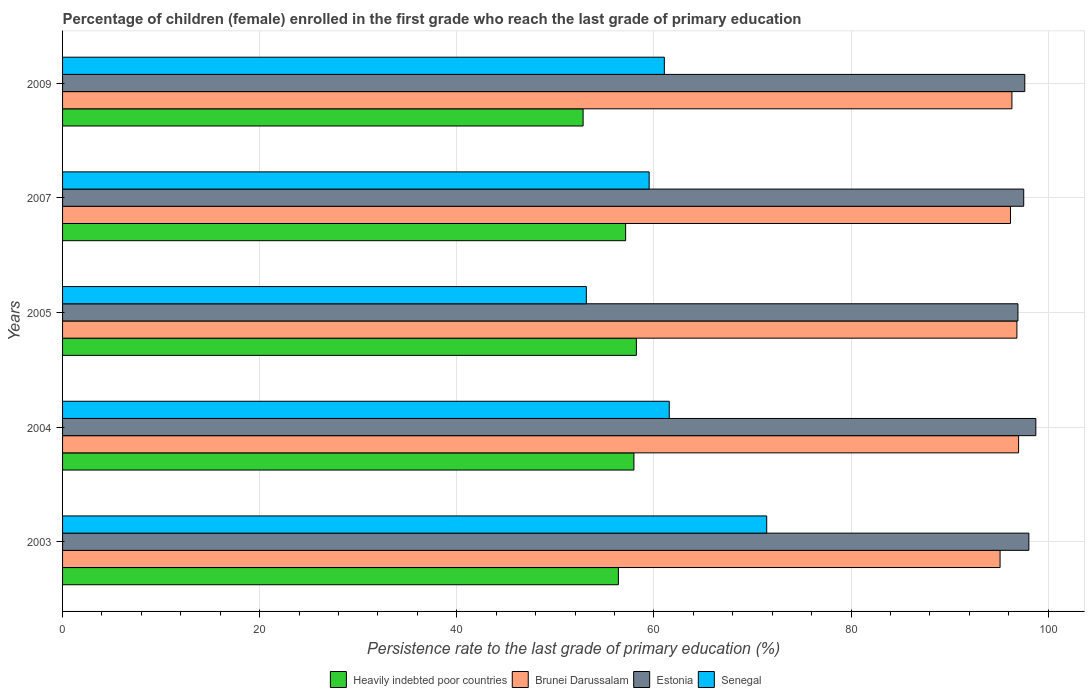Are the number of bars on each tick of the Y-axis equal?
Your response must be concise. Yes. How many bars are there on the 4th tick from the top?
Provide a short and direct response. 4. What is the label of the 3rd group of bars from the top?
Your answer should be compact. 2005. What is the persistence rate of children in Brunei Darussalam in 2003?
Offer a terse response. 95.13. Across all years, what is the maximum persistence rate of children in Estonia?
Give a very brief answer. 98.75. Across all years, what is the minimum persistence rate of children in Estonia?
Make the answer very short. 96.94. In which year was the persistence rate of children in Estonia maximum?
Your answer should be compact. 2004. In which year was the persistence rate of children in Brunei Darussalam minimum?
Give a very brief answer. 2003. What is the total persistence rate of children in Estonia in the graph?
Keep it short and to the point. 488.9. What is the difference between the persistence rate of children in Heavily indebted poor countries in 2003 and that in 2005?
Make the answer very short. -1.83. What is the difference between the persistence rate of children in Brunei Darussalam in 2005 and the persistence rate of children in Heavily indebted poor countries in 2003?
Make the answer very short. 40.44. What is the average persistence rate of children in Senegal per year?
Your answer should be compact. 61.35. In the year 2009, what is the difference between the persistence rate of children in Brunei Darussalam and persistence rate of children in Heavily indebted poor countries?
Keep it short and to the point. 43.51. What is the ratio of the persistence rate of children in Heavily indebted poor countries in 2003 to that in 2004?
Ensure brevity in your answer.  0.97. Is the persistence rate of children in Brunei Darussalam in 2005 less than that in 2009?
Give a very brief answer. No. Is the difference between the persistence rate of children in Brunei Darussalam in 2004 and 2009 greater than the difference between the persistence rate of children in Heavily indebted poor countries in 2004 and 2009?
Your response must be concise. No. What is the difference between the highest and the second highest persistence rate of children in Senegal?
Make the answer very short. 9.89. What is the difference between the highest and the lowest persistence rate of children in Heavily indebted poor countries?
Ensure brevity in your answer.  5.4. Is the sum of the persistence rate of children in Heavily indebted poor countries in 2003 and 2004 greater than the maximum persistence rate of children in Brunei Darussalam across all years?
Offer a very short reply. Yes. What does the 1st bar from the top in 2003 represents?
Your response must be concise. Senegal. What does the 2nd bar from the bottom in 2005 represents?
Make the answer very short. Brunei Darussalam. Are all the bars in the graph horizontal?
Your answer should be compact. Yes. What is the difference between two consecutive major ticks on the X-axis?
Your response must be concise. 20. Does the graph contain any zero values?
Your answer should be compact. No. Does the graph contain grids?
Provide a short and direct response. Yes. How many legend labels are there?
Make the answer very short. 4. How are the legend labels stacked?
Make the answer very short. Horizontal. What is the title of the graph?
Ensure brevity in your answer.  Percentage of children (female) enrolled in the first grade who reach the last grade of primary education. Does "Turks and Caicos Islands" appear as one of the legend labels in the graph?
Your answer should be very brief. No. What is the label or title of the X-axis?
Keep it short and to the point. Persistence rate to the last grade of primary education (%). What is the Persistence rate to the last grade of primary education (%) of Heavily indebted poor countries in 2003?
Provide a short and direct response. 56.4. What is the Persistence rate to the last grade of primary education (%) in Brunei Darussalam in 2003?
Offer a terse response. 95.13. What is the Persistence rate to the last grade of primary education (%) in Estonia in 2003?
Keep it short and to the point. 98.05. What is the Persistence rate to the last grade of primary education (%) in Senegal in 2003?
Ensure brevity in your answer.  71.45. What is the Persistence rate to the last grade of primary education (%) of Heavily indebted poor countries in 2004?
Offer a terse response. 57.97. What is the Persistence rate to the last grade of primary education (%) in Brunei Darussalam in 2004?
Offer a terse response. 97.01. What is the Persistence rate to the last grade of primary education (%) in Estonia in 2004?
Your response must be concise. 98.75. What is the Persistence rate to the last grade of primary education (%) of Senegal in 2004?
Your answer should be very brief. 61.56. What is the Persistence rate to the last grade of primary education (%) in Heavily indebted poor countries in 2005?
Keep it short and to the point. 58.22. What is the Persistence rate to the last grade of primary education (%) of Brunei Darussalam in 2005?
Ensure brevity in your answer.  96.83. What is the Persistence rate to the last grade of primary education (%) of Estonia in 2005?
Your answer should be compact. 96.94. What is the Persistence rate to the last grade of primary education (%) in Senegal in 2005?
Keep it short and to the point. 53.14. What is the Persistence rate to the last grade of primary education (%) of Heavily indebted poor countries in 2007?
Make the answer very short. 57.13. What is the Persistence rate to the last grade of primary education (%) in Brunei Darussalam in 2007?
Provide a succinct answer. 96.18. What is the Persistence rate to the last grade of primary education (%) of Estonia in 2007?
Give a very brief answer. 97.52. What is the Persistence rate to the last grade of primary education (%) of Senegal in 2007?
Your answer should be very brief. 59.52. What is the Persistence rate to the last grade of primary education (%) in Heavily indebted poor countries in 2009?
Provide a short and direct response. 52.82. What is the Persistence rate to the last grade of primary education (%) of Brunei Darussalam in 2009?
Offer a very short reply. 96.33. What is the Persistence rate to the last grade of primary education (%) of Estonia in 2009?
Your response must be concise. 97.63. What is the Persistence rate to the last grade of primary education (%) in Senegal in 2009?
Offer a very short reply. 61.06. Across all years, what is the maximum Persistence rate to the last grade of primary education (%) of Heavily indebted poor countries?
Offer a very short reply. 58.22. Across all years, what is the maximum Persistence rate to the last grade of primary education (%) of Brunei Darussalam?
Your answer should be compact. 97.01. Across all years, what is the maximum Persistence rate to the last grade of primary education (%) of Estonia?
Give a very brief answer. 98.75. Across all years, what is the maximum Persistence rate to the last grade of primary education (%) in Senegal?
Your answer should be compact. 71.45. Across all years, what is the minimum Persistence rate to the last grade of primary education (%) of Heavily indebted poor countries?
Make the answer very short. 52.82. Across all years, what is the minimum Persistence rate to the last grade of primary education (%) in Brunei Darussalam?
Ensure brevity in your answer.  95.13. Across all years, what is the minimum Persistence rate to the last grade of primary education (%) of Estonia?
Your response must be concise. 96.94. Across all years, what is the minimum Persistence rate to the last grade of primary education (%) in Senegal?
Give a very brief answer. 53.14. What is the total Persistence rate to the last grade of primary education (%) of Heavily indebted poor countries in the graph?
Keep it short and to the point. 282.54. What is the total Persistence rate to the last grade of primary education (%) in Brunei Darussalam in the graph?
Your answer should be very brief. 481.47. What is the total Persistence rate to the last grade of primary education (%) of Estonia in the graph?
Give a very brief answer. 488.9. What is the total Persistence rate to the last grade of primary education (%) of Senegal in the graph?
Give a very brief answer. 306.73. What is the difference between the Persistence rate to the last grade of primary education (%) in Heavily indebted poor countries in 2003 and that in 2004?
Provide a succinct answer. -1.58. What is the difference between the Persistence rate to the last grade of primary education (%) in Brunei Darussalam in 2003 and that in 2004?
Offer a very short reply. -1.88. What is the difference between the Persistence rate to the last grade of primary education (%) in Estonia in 2003 and that in 2004?
Ensure brevity in your answer.  -0.71. What is the difference between the Persistence rate to the last grade of primary education (%) in Senegal in 2003 and that in 2004?
Keep it short and to the point. 9.89. What is the difference between the Persistence rate to the last grade of primary education (%) of Heavily indebted poor countries in 2003 and that in 2005?
Offer a very short reply. -1.83. What is the difference between the Persistence rate to the last grade of primary education (%) of Brunei Darussalam in 2003 and that in 2005?
Your answer should be compact. -1.71. What is the difference between the Persistence rate to the last grade of primary education (%) in Estonia in 2003 and that in 2005?
Your response must be concise. 1.11. What is the difference between the Persistence rate to the last grade of primary education (%) of Senegal in 2003 and that in 2005?
Your answer should be compact. 18.3. What is the difference between the Persistence rate to the last grade of primary education (%) in Heavily indebted poor countries in 2003 and that in 2007?
Keep it short and to the point. -0.73. What is the difference between the Persistence rate to the last grade of primary education (%) in Brunei Darussalam in 2003 and that in 2007?
Your answer should be very brief. -1.06. What is the difference between the Persistence rate to the last grade of primary education (%) of Estonia in 2003 and that in 2007?
Give a very brief answer. 0.52. What is the difference between the Persistence rate to the last grade of primary education (%) in Senegal in 2003 and that in 2007?
Your answer should be compact. 11.93. What is the difference between the Persistence rate to the last grade of primary education (%) of Heavily indebted poor countries in 2003 and that in 2009?
Make the answer very short. 3.58. What is the difference between the Persistence rate to the last grade of primary education (%) of Brunei Darussalam in 2003 and that in 2009?
Your answer should be compact. -1.2. What is the difference between the Persistence rate to the last grade of primary education (%) in Estonia in 2003 and that in 2009?
Provide a short and direct response. 0.41. What is the difference between the Persistence rate to the last grade of primary education (%) in Senegal in 2003 and that in 2009?
Your answer should be compact. 10.39. What is the difference between the Persistence rate to the last grade of primary education (%) of Heavily indebted poor countries in 2004 and that in 2005?
Provide a short and direct response. -0.25. What is the difference between the Persistence rate to the last grade of primary education (%) in Brunei Darussalam in 2004 and that in 2005?
Your answer should be compact. 0.17. What is the difference between the Persistence rate to the last grade of primary education (%) in Estonia in 2004 and that in 2005?
Your answer should be compact. 1.81. What is the difference between the Persistence rate to the last grade of primary education (%) of Senegal in 2004 and that in 2005?
Provide a short and direct response. 8.41. What is the difference between the Persistence rate to the last grade of primary education (%) of Heavily indebted poor countries in 2004 and that in 2007?
Keep it short and to the point. 0.84. What is the difference between the Persistence rate to the last grade of primary education (%) of Brunei Darussalam in 2004 and that in 2007?
Offer a terse response. 0.82. What is the difference between the Persistence rate to the last grade of primary education (%) in Estonia in 2004 and that in 2007?
Your answer should be compact. 1.23. What is the difference between the Persistence rate to the last grade of primary education (%) of Senegal in 2004 and that in 2007?
Your answer should be very brief. 2.04. What is the difference between the Persistence rate to the last grade of primary education (%) in Heavily indebted poor countries in 2004 and that in 2009?
Provide a succinct answer. 5.16. What is the difference between the Persistence rate to the last grade of primary education (%) of Brunei Darussalam in 2004 and that in 2009?
Offer a terse response. 0.68. What is the difference between the Persistence rate to the last grade of primary education (%) in Estonia in 2004 and that in 2009?
Your response must be concise. 1.12. What is the difference between the Persistence rate to the last grade of primary education (%) of Senegal in 2004 and that in 2009?
Provide a short and direct response. 0.5. What is the difference between the Persistence rate to the last grade of primary education (%) in Heavily indebted poor countries in 2005 and that in 2007?
Provide a short and direct response. 1.09. What is the difference between the Persistence rate to the last grade of primary education (%) in Brunei Darussalam in 2005 and that in 2007?
Make the answer very short. 0.65. What is the difference between the Persistence rate to the last grade of primary education (%) in Estonia in 2005 and that in 2007?
Offer a very short reply. -0.59. What is the difference between the Persistence rate to the last grade of primary education (%) in Senegal in 2005 and that in 2007?
Keep it short and to the point. -6.38. What is the difference between the Persistence rate to the last grade of primary education (%) of Heavily indebted poor countries in 2005 and that in 2009?
Provide a succinct answer. 5.4. What is the difference between the Persistence rate to the last grade of primary education (%) of Brunei Darussalam in 2005 and that in 2009?
Provide a succinct answer. 0.51. What is the difference between the Persistence rate to the last grade of primary education (%) of Estonia in 2005 and that in 2009?
Your response must be concise. -0.69. What is the difference between the Persistence rate to the last grade of primary education (%) of Senegal in 2005 and that in 2009?
Your response must be concise. -7.91. What is the difference between the Persistence rate to the last grade of primary education (%) of Heavily indebted poor countries in 2007 and that in 2009?
Ensure brevity in your answer.  4.31. What is the difference between the Persistence rate to the last grade of primary education (%) of Brunei Darussalam in 2007 and that in 2009?
Offer a very short reply. -0.14. What is the difference between the Persistence rate to the last grade of primary education (%) of Estonia in 2007 and that in 2009?
Ensure brevity in your answer.  -0.11. What is the difference between the Persistence rate to the last grade of primary education (%) of Senegal in 2007 and that in 2009?
Provide a succinct answer. -1.54. What is the difference between the Persistence rate to the last grade of primary education (%) in Heavily indebted poor countries in 2003 and the Persistence rate to the last grade of primary education (%) in Brunei Darussalam in 2004?
Provide a short and direct response. -40.61. What is the difference between the Persistence rate to the last grade of primary education (%) of Heavily indebted poor countries in 2003 and the Persistence rate to the last grade of primary education (%) of Estonia in 2004?
Ensure brevity in your answer.  -42.36. What is the difference between the Persistence rate to the last grade of primary education (%) of Heavily indebted poor countries in 2003 and the Persistence rate to the last grade of primary education (%) of Senegal in 2004?
Your answer should be very brief. -5.16. What is the difference between the Persistence rate to the last grade of primary education (%) in Brunei Darussalam in 2003 and the Persistence rate to the last grade of primary education (%) in Estonia in 2004?
Keep it short and to the point. -3.63. What is the difference between the Persistence rate to the last grade of primary education (%) in Brunei Darussalam in 2003 and the Persistence rate to the last grade of primary education (%) in Senegal in 2004?
Offer a terse response. 33.57. What is the difference between the Persistence rate to the last grade of primary education (%) of Estonia in 2003 and the Persistence rate to the last grade of primary education (%) of Senegal in 2004?
Give a very brief answer. 36.49. What is the difference between the Persistence rate to the last grade of primary education (%) of Heavily indebted poor countries in 2003 and the Persistence rate to the last grade of primary education (%) of Brunei Darussalam in 2005?
Keep it short and to the point. -40.44. What is the difference between the Persistence rate to the last grade of primary education (%) of Heavily indebted poor countries in 2003 and the Persistence rate to the last grade of primary education (%) of Estonia in 2005?
Your answer should be very brief. -40.54. What is the difference between the Persistence rate to the last grade of primary education (%) of Heavily indebted poor countries in 2003 and the Persistence rate to the last grade of primary education (%) of Senegal in 2005?
Give a very brief answer. 3.25. What is the difference between the Persistence rate to the last grade of primary education (%) of Brunei Darussalam in 2003 and the Persistence rate to the last grade of primary education (%) of Estonia in 2005?
Provide a short and direct response. -1.81. What is the difference between the Persistence rate to the last grade of primary education (%) in Brunei Darussalam in 2003 and the Persistence rate to the last grade of primary education (%) in Senegal in 2005?
Give a very brief answer. 41.98. What is the difference between the Persistence rate to the last grade of primary education (%) of Estonia in 2003 and the Persistence rate to the last grade of primary education (%) of Senegal in 2005?
Provide a succinct answer. 44.9. What is the difference between the Persistence rate to the last grade of primary education (%) of Heavily indebted poor countries in 2003 and the Persistence rate to the last grade of primary education (%) of Brunei Darussalam in 2007?
Your answer should be compact. -39.79. What is the difference between the Persistence rate to the last grade of primary education (%) in Heavily indebted poor countries in 2003 and the Persistence rate to the last grade of primary education (%) in Estonia in 2007?
Your answer should be very brief. -41.13. What is the difference between the Persistence rate to the last grade of primary education (%) of Heavily indebted poor countries in 2003 and the Persistence rate to the last grade of primary education (%) of Senegal in 2007?
Offer a terse response. -3.12. What is the difference between the Persistence rate to the last grade of primary education (%) in Brunei Darussalam in 2003 and the Persistence rate to the last grade of primary education (%) in Estonia in 2007?
Your answer should be very brief. -2.4. What is the difference between the Persistence rate to the last grade of primary education (%) in Brunei Darussalam in 2003 and the Persistence rate to the last grade of primary education (%) in Senegal in 2007?
Provide a short and direct response. 35.61. What is the difference between the Persistence rate to the last grade of primary education (%) in Estonia in 2003 and the Persistence rate to the last grade of primary education (%) in Senegal in 2007?
Give a very brief answer. 38.53. What is the difference between the Persistence rate to the last grade of primary education (%) of Heavily indebted poor countries in 2003 and the Persistence rate to the last grade of primary education (%) of Brunei Darussalam in 2009?
Offer a very short reply. -39.93. What is the difference between the Persistence rate to the last grade of primary education (%) in Heavily indebted poor countries in 2003 and the Persistence rate to the last grade of primary education (%) in Estonia in 2009?
Give a very brief answer. -41.24. What is the difference between the Persistence rate to the last grade of primary education (%) in Heavily indebted poor countries in 2003 and the Persistence rate to the last grade of primary education (%) in Senegal in 2009?
Offer a terse response. -4.66. What is the difference between the Persistence rate to the last grade of primary education (%) in Brunei Darussalam in 2003 and the Persistence rate to the last grade of primary education (%) in Estonia in 2009?
Provide a short and direct response. -2.51. What is the difference between the Persistence rate to the last grade of primary education (%) in Brunei Darussalam in 2003 and the Persistence rate to the last grade of primary education (%) in Senegal in 2009?
Your response must be concise. 34.07. What is the difference between the Persistence rate to the last grade of primary education (%) of Estonia in 2003 and the Persistence rate to the last grade of primary education (%) of Senegal in 2009?
Provide a short and direct response. 36.99. What is the difference between the Persistence rate to the last grade of primary education (%) of Heavily indebted poor countries in 2004 and the Persistence rate to the last grade of primary education (%) of Brunei Darussalam in 2005?
Your answer should be compact. -38.86. What is the difference between the Persistence rate to the last grade of primary education (%) in Heavily indebted poor countries in 2004 and the Persistence rate to the last grade of primary education (%) in Estonia in 2005?
Make the answer very short. -38.97. What is the difference between the Persistence rate to the last grade of primary education (%) in Heavily indebted poor countries in 2004 and the Persistence rate to the last grade of primary education (%) in Senegal in 2005?
Your answer should be compact. 4.83. What is the difference between the Persistence rate to the last grade of primary education (%) in Brunei Darussalam in 2004 and the Persistence rate to the last grade of primary education (%) in Estonia in 2005?
Your answer should be compact. 0.07. What is the difference between the Persistence rate to the last grade of primary education (%) of Brunei Darussalam in 2004 and the Persistence rate to the last grade of primary education (%) of Senegal in 2005?
Give a very brief answer. 43.86. What is the difference between the Persistence rate to the last grade of primary education (%) in Estonia in 2004 and the Persistence rate to the last grade of primary education (%) in Senegal in 2005?
Offer a very short reply. 45.61. What is the difference between the Persistence rate to the last grade of primary education (%) in Heavily indebted poor countries in 2004 and the Persistence rate to the last grade of primary education (%) in Brunei Darussalam in 2007?
Give a very brief answer. -38.21. What is the difference between the Persistence rate to the last grade of primary education (%) of Heavily indebted poor countries in 2004 and the Persistence rate to the last grade of primary education (%) of Estonia in 2007?
Give a very brief answer. -39.55. What is the difference between the Persistence rate to the last grade of primary education (%) in Heavily indebted poor countries in 2004 and the Persistence rate to the last grade of primary education (%) in Senegal in 2007?
Your answer should be very brief. -1.55. What is the difference between the Persistence rate to the last grade of primary education (%) in Brunei Darussalam in 2004 and the Persistence rate to the last grade of primary education (%) in Estonia in 2007?
Offer a terse response. -0.52. What is the difference between the Persistence rate to the last grade of primary education (%) of Brunei Darussalam in 2004 and the Persistence rate to the last grade of primary education (%) of Senegal in 2007?
Offer a terse response. 37.49. What is the difference between the Persistence rate to the last grade of primary education (%) in Estonia in 2004 and the Persistence rate to the last grade of primary education (%) in Senegal in 2007?
Give a very brief answer. 39.23. What is the difference between the Persistence rate to the last grade of primary education (%) in Heavily indebted poor countries in 2004 and the Persistence rate to the last grade of primary education (%) in Brunei Darussalam in 2009?
Your answer should be very brief. -38.35. What is the difference between the Persistence rate to the last grade of primary education (%) of Heavily indebted poor countries in 2004 and the Persistence rate to the last grade of primary education (%) of Estonia in 2009?
Give a very brief answer. -39.66. What is the difference between the Persistence rate to the last grade of primary education (%) in Heavily indebted poor countries in 2004 and the Persistence rate to the last grade of primary education (%) in Senegal in 2009?
Offer a terse response. -3.08. What is the difference between the Persistence rate to the last grade of primary education (%) in Brunei Darussalam in 2004 and the Persistence rate to the last grade of primary education (%) in Estonia in 2009?
Your response must be concise. -0.63. What is the difference between the Persistence rate to the last grade of primary education (%) in Brunei Darussalam in 2004 and the Persistence rate to the last grade of primary education (%) in Senegal in 2009?
Offer a terse response. 35.95. What is the difference between the Persistence rate to the last grade of primary education (%) in Estonia in 2004 and the Persistence rate to the last grade of primary education (%) in Senegal in 2009?
Provide a short and direct response. 37.7. What is the difference between the Persistence rate to the last grade of primary education (%) in Heavily indebted poor countries in 2005 and the Persistence rate to the last grade of primary education (%) in Brunei Darussalam in 2007?
Offer a very short reply. -37.96. What is the difference between the Persistence rate to the last grade of primary education (%) in Heavily indebted poor countries in 2005 and the Persistence rate to the last grade of primary education (%) in Estonia in 2007?
Offer a terse response. -39.3. What is the difference between the Persistence rate to the last grade of primary education (%) in Heavily indebted poor countries in 2005 and the Persistence rate to the last grade of primary education (%) in Senegal in 2007?
Offer a terse response. -1.3. What is the difference between the Persistence rate to the last grade of primary education (%) in Brunei Darussalam in 2005 and the Persistence rate to the last grade of primary education (%) in Estonia in 2007?
Give a very brief answer. -0.69. What is the difference between the Persistence rate to the last grade of primary education (%) in Brunei Darussalam in 2005 and the Persistence rate to the last grade of primary education (%) in Senegal in 2007?
Your answer should be very brief. 37.31. What is the difference between the Persistence rate to the last grade of primary education (%) of Estonia in 2005 and the Persistence rate to the last grade of primary education (%) of Senegal in 2007?
Provide a short and direct response. 37.42. What is the difference between the Persistence rate to the last grade of primary education (%) of Heavily indebted poor countries in 2005 and the Persistence rate to the last grade of primary education (%) of Brunei Darussalam in 2009?
Keep it short and to the point. -38.11. What is the difference between the Persistence rate to the last grade of primary education (%) in Heavily indebted poor countries in 2005 and the Persistence rate to the last grade of primary education (%) in Estonia in 2009?
Offer a terse response. -39.41. What is the difference between the Persistence rate to the last grade of primary education (%) in Heavily indebted poor countries in 2005 and the Persistence rate to the last grade of primary education (%) in Senegal in 2009?
Your answer should be compact. -2.84. What is the difference between the Persistence rate to the last grade of primary education (%) of Brunei Darussalam in 2005 and the Persistence rate to the last grade of primary education (%) of Estonia in 2009?
Your response must be concise. -0.8. What is the difference between the Persistence rate to the last grade of primary education (%) of Brunei Darussalam in 2005 and the Persistence rate to the last grade of primary education (%) of Senegal in 2009?
Provide a short and direct response. 35.77. What is the difference between the Persistence rate to the last grade of primary education (%) in Estonia in 2005 and the Persistence rate to the last grade of primary education (%) in Senegal in 2009?
Offer a very short reply. 35.88. What is the difference between the Persistence rate to the last grade of primary education (%) in Heavily indebted poor countries in 2007 and the Persistence rate to the last grade of primary education (%) in Brunei Darussalam in 2009?
Provide a succinct answer. -39.2. What is the difference between the Persistence rate to the last grade of primary education (%) of Heavily indebted poor countries in 2007 and the Persistence rate to the last grade of primary education (%) of Estonia in 2009?
Keep it short and to the point. -40.5. What is the difference between the Persistence rate to the last grade of primary education (%) in Heavily indebted poor countries in 2007 and the Persistence rate to the last grade of primary education (%) in Senegal in 2009?
Your answer should be very brief. -3.93. What is the difference between the Persistence rate to the last grade of primary education (%) in Brunei Darussalam in 2007 and the Persistence rate to the last grade of primary education (%) in Estonia in 2009?
Make the answer very short. -1.45. What is the difference between the Persistence rate to the last grade of primary education (%) of Brunei Darussalam in 2007 and the Persistence rate to the last grade of primary education (%) of Senegal in 2009?
Your answer should be compact. 35.12. What is the difference between the Persistence rate to the last grade of primary education (%) of Estonia in 2007 and the Persistence rate to the last grade of primary education (%) of Senegal in 2009?
Offer a terse response. 36.47. What is the average Persistence rate to the last grade of primary education (%) in Heavily indebted poor countries per year?
Make the answer very short. 56.51. What is the average Persistence rate to the last grade of primary education (%) in Brunei Darussalam per year?
Ensure brevity in your answer.  96.29. What is the average Persistence rate to the last grade of primary education (%) of Estonia per year?
Offer a terse response. 97.78. What is the average Persistence rate to the last grade of primary education (%) of Senegal per year?
Offer a terse response. 61.35. In the year 2003, what is the difference between the Persistence rate to the last grade of primary education (%) in Heavily indebted poor countries and Persistence rate to the last grade of primary education (%) in Brunei Darussalam?
Provide a short and direct response. -38.73. In the year 2003, what is the difference between the Persistence rate to the last grade of primary education (%) of Heavily indebted poor countries and Persistence rate to the last grade of primary education (%) of Estonia?
Make the answer very short. -41.65. In the year 2003, what is the difference between the Persistence rate to the last grade of primary education (%) in Heavily indebted poor countries and Persistence rate to the last grade of primary education (%) in Senegal?
Your answer should be compact. -15.05. In the year 2003, what is the difference between the Persistence rate to the last grade of primary education (%) in Brunei Darussalam and Persistence rate to the last grade of primary education (%) in Estonia?
Provide a short and direct response. -2.92. In the year 2003, what is the difference between the Persistence rate to the last grade of primary education (%) of Brunei Darussalam and Persistence rate to the last grade of primary education (%) of Senegal?
Make the answer very short. 23.68. In the year 2003, what is the difference between the Persistence rate to the last grade of primary education (%) in Estonia and Persistence rate to the last grade of primary education (%) in Senegal?
Keep it short and to the point. 26.6. In the year 2004, what is the difference between the Persistence rate to the last grade of primary education (%) of Heavily indebted poor countries and Persistence rate to the last grade of primary education (%) of Brunei Darussalam?
Provide a succinct answer. -39.03. In the year 2004, what is the difference between the Persistence rate to the last grade of primary education (%) of Heavily indebted poor countries and Persistence rate to the last grade of primary education (%) of Estonia?
Your response must be concise. -40.78. In the year 2004, what is the difference between the Persistence rate to the last grade of primary education (%) of Heavily indebted poor countries and Persistence rate to the last grade of primary education (%) of Senegal?
Your response must be concise. -3.59. In the year 2004, what is the difference between the Persistence rate to the last grade of primary education (%) in Brunei Darussalam and Persistence rate to the last grade of primary education (%) in Estonia?
Offer a terse response. -1.75. In the year 2004, what is the difference between the Persistence rate to the last grade of primary education (%) in Brunei Darussalam and Persistence rate to the last grade of primary education (%) in Senegal?
Offer a very short reply. 35.45. In the year 2004, what is the difference between the Persistence rate to the last grade of primary education (%) in Estonia and Persistence rate to the last grade of primary education (%) in Senegal?
Offer a very short reply. 37.19. In the year 2005, what is the difference between the Persistence rate to the last grade of primary education (%) in Heavily indebted poor countries and Persistence rate to the last grade of primary education (%) in Brunei Darussalam?
Provide a succinct answer. -38.61. In the year 2005, what is the difference between the Persistence rate to the last grade of primary education (%) of Heavily indebted poor countries and Persistence rate to the last grade of primary education (%) of Estonia?
Give a very brief answer. -38.72. In the year 2005, what is the difference between the Persistence rate to the last grade of primary education (%) of Heavily indebted poor countries and Persistence rate to the last grade of primary education (%) of Senegal?
Offer a very short reply. 5.08. In the year 2005, what is the difference between the Persistence rate to the last grade of primary education (%) in Brunei Darussalam and Persistence rate to the last grade of primary education (%) in Estonia?
Offer a very short reply. -0.11. In the year 2005, what is the difference between the Persistence rate to the last grade of primary education (%) of Brunei Darussalam and Persistence rate to the last grade of primary education (%) of Senegal?
Your answer should be very brief. 43.69. In the year 2005, what is the difference between the Persistence rate to the last grade of primary education (%) in Estonia and Persistence rate to the last grade of primary education (%) in Senegal?
Offer a very short reply. 43.79. In the year 2007, what is the difference between the Persistence rate to the last grade of primary education (%) of Heavily indebted poor countries and Persistence rate to the last grade of primary education (%) of Brunei Darussalam?
Keep it short and to the point. -39.05. In the year 2007, what is the difference between the Persistence rate to the last grade of primary education (%) in Heavily indebted poor countries and Persistence rate to the last grade of primary education (%) in Estonia?
Offer a terse response. -40.39. In the year 2007, what is the difference between the Persistence rate to the last grade of primary education (%) in Heavily indebted poor countries and Persistence rate to the last grade of primary education (%) in Senegal?
Give a very brief answer. -2.39. In the year 2007, what is the difference between the Persistence rate to the last grade of primary education (%) of Brunei Darussalam and Persistence rate to the last grade of primary education (%) of Estonia?
Offer a very short reply. -1.34. In the year 2007, what is the difference between the Persistence rate to the last grade of primary education (%) in Brunei Darussalam and Persistence rate to the last grade of primary education (%) in Senegal?
Offer a very short reply. 36.66. In the year 2007, what is the difference between the Persistence rate to the last grade of primary education (%) of Estonia and Persistence rate to the last grade of primary education (%) of Senegal?
Your response must be concise. 38.01. In the year 2009, what is the difference between the Persistence rate to the last grade of primary education (%) in Heavily indebted poor countries and Persistence rate to the last grade of primary education (%) in Brunei Darussalam?
Make the answer very short. -43.51. In the year 2009, what is the difference between the Persistence rate to the last grade of primary education (%) of Heavily indebted poor countries and Persistence rate to the last grade of primary education (%) of Estonia?
Make the answer very short. -44.81. In the year 2009, what is the difference between the Persistence rate to the last grade of primary education (%) of Heavily indebted poor countries and Persistence rate to the last grade of primary education (%) of Senegal?
Offer a terse response. -8.24. In the year 2009, what is the difference between the Persistence rate to the last grade of primary education (%) of Brunei Darussalam and Persistence rate to the last grade of primary education (%) of Estonia?
Offer a very short reply. -1.31. In the year 2009, what is the difference between the Persistence rate to the last grade of primary education (%) in Brunei Darussalam and Persistence rate to the last grade of primary education (%) in Senegal?
Give a very brief answer. 35.27. In the year 2009, what is the difference between the Persistence rate to the last grade of primary education (%) in Estonia and Persistence rate to the last grade of primary education (%) in Senegal?
Provide a succinct answer. 36.57. What is the ratio of the Persistence rate to the last grade of primary education (%) of Heavily indebted poor countries in 2003 to that in 2004?
Keep it short and to the point. 0.97. What is the ratio of the Persistence rate to the last grade of primary education (%) in Brunei Darussalam in 2003 to that in 2004?
Provide a succinct answer. 0.98. What is the ratio of the Persistence rate to the last grade of primary education (%) of Senegal in 2003 to that in 2004?
Ensure brevity in your answer.  1.16. What is the ratio of the Persistence rate to the last grade of primary education (%) of Heavily indebted poor countries in 2003 to that in 2005?
Ensure brevity in your answer.  0.97. What is the ratio of the Persistence rate to the last grade of primary education (%) of Brunei Darussalam in 2003 to that in 2005?
Provide a short and direct response. 0.98. What is the ratio of the Persistence rate to the last grade of primary education (%) in Estonia in 2003 to that in 2005?
Give a very brief answer. 1.01. What is the ratio of the Persistence rate to the last grade of primary education (%) of Senegal in 2003 to that in 2005?
Offer a very short reply. 1.34. What is the ratio of the Persistence rate to the last grade of primary education (%) of Heavily indebted poor countries in 2003 to that in 2007?
Give a very brief answer. 0.99. What is the ratio of the Persistence rate to the last grade of primary education (%) of Brunei Darussalam in 2003 to that in 2007?
Offer a terse response. 0.99. What is the ratio of the Persistence rate to the last grade of primary education (%) in Estonia in 2003 to that in 2007?
Provide a short and direct response. 1.01. What is the ratio of the Persistence rate to the last grade of primary education (%) of Senegal in 2003 to that in 2007?
Make the answer very short. 1.2. What is the ratio of the Persistence rate to the last grade of primary education (%) in Heavily indebted poor countries in 2003 to that in 2009?
Keep it short and to the point. 1.07. What is the ratio of the Persistence rate to the last grade of primary education (%) of Brunei Darussalam in 2003 to that in 2009?
Ensure brevity in your answer.  0.99. What is the ratio of the Persistence rate to the last grade of primary education (%) of Estonia in 2003 to that in 2009?
Ensure brevity in your answer.  1. What is the ratio of the Persistence rate to the last grade of primary education (%) in Senegal in 2003 to that in 2009?
Your answer should be compact. 1.17. What is the ratio of the Persistence rate to the last grade of primary education (%) in Brunei Darussalam in 2004 to that in 2005?
Ensure brevity in your answer.  1. What is the ratio of the Persistence rate to the last grade of primary education (%) of Estonia in 2004 to that in 2005?
Give a very brief answer. 1.02. What is the ratio of the Persistence rate to the last grade of primary education (%) of Senegal in 2004 to that in 2005?
Keep it short and to the point. 1.16. What is the ratio of the Persistence rate to the last grade of primary education (%) in Heavily indebted poor countries in 2004 to that in 2007?
Ensure brevity in your answer.  1.01. What is the ratio of the Persistence rate to the last grade of primary education (%) of Brunei Darussalam in 2004 to that in 2007?
Offer a terse response. 1.01. What is the ratio of the Persistence rate to the last grade of primary education (%) of Estonia in 2004 to that in 2007?
Your answer should be very brief. 1.01. What is the ratio of the Persistence rate to the last grade of primary education (%) in Senegal in 2004 to that in 2007?
Provide a short and direct response. 1.03. What is the ratio of the Persistence rate to the last grade of primary education (%) in Heavily indebted poor countries in 2004 to that in 2009?
Your response must be concise. 1.1. What is the ratio of the Persistence rate to the last grade of primary education (%) of Brunei Darussalam in 2004 to that in 2009?
Your answer should be compact. 1.01. What is the ratio of the Persistence rate to the last grade of primary education (%) in Estonia in 2004 to that in 2009?
Ensure brevity in your answer.  1.01. What is the ratio of the Persistence rate to the last grade of primary education (%) in Senegal in 2004 to that in 2009?
Your answer should be compact. 1.01. What is the ratio of the Persistence rate to the last grade of primary education (%) of Heavily indebted poor countries in 2005 to that in 2007?
Your answer should be very brief. 1.02. What is the ratio of the Persistence rate to the last grade of primary education (%) in Brunei Darussalam in 2005 to that in 2007?
Offer a terse response. 1.01. What is the ratio of the Persistence rate to the last grade of primary education (%) of Estonia in 2005 to that in 2007?
Provide a short and direct response. 0.99. What is the ratio of the Persistence rate to the last grade of primary education (%) in Senegal in 2005 to that in 2007?
Your response must be concise. 0.89. What is the ratio of the Persistence rate to the last grade of primary education (%) in Heavily indebted poor countries in 2005 to that in 2009?
Provide a succinct answer. 1.1. What is the ratio of the Persistence rate to the last grade of primary education (%) in Brunei Darussalam in 2005 to that in 2009?
Give a very brief answer. 1.01. What is the ratio of the Persistence rate to the last grade of primary education (%) of Estonia in 2005 to that in 2009?
Ensure brevity in your answer.  0.99. What is the ratio of the Persistence rate to the last grade of primary education (%) of Senegal in 2005 to that in 2009?
Your answer should be very brief. 0.87. What is the ratio of the Persistence rate to the last grade of primary education (%) in Heavily indebted poor countries in 2007 to that in 2009?
Provide a succinct answer. 1.08. What is the ratio of the Persistence rate to the last grade of primary education (%) of Senegal in 2007 to that in 2009?
Make the answer very short. 0.97. What is the difference between the highest and the second highest Persistence rate to the last grade of primary education (%) of Heavily indebted poor countries?
Offer a terse response. 0.25. What is the difference between the highest and the second highest Persistence rate to the last grade of primary education (%) of Brunei Darussalam?
Give a very brief answer. 0.17. What is the difference between the highest and the second highest Persistence rate to the last grade of primary education (%) of Estonia?
Your answer should be very brief. 0.71. What is the difference between the highest and the second highest Persistence rate to the last grade of primary education (%) of Senegal?
Provide a short and direct response. 9.89. What is the difference between the highest and the lowest Persistence rate to the last grade of primary education (%) of Heavily indebted poor countries?
Offer a very short reply. 5.4. What is the difference between the highest and the lowest Persistence rate to the last grade of primary education (%) in Brunei Darussalam?
Your response must be concise. 1.88. What is the difference between the highest and the lowest Persistence rate to the last grade of primary education (%) in Estonia?
Your answer should be very brief. 1.81. What is the difference between the highest and the lowest Persistence rate to the last grade of primary education (%) in Senegal?
Keep it short and to the point. 18.3. 